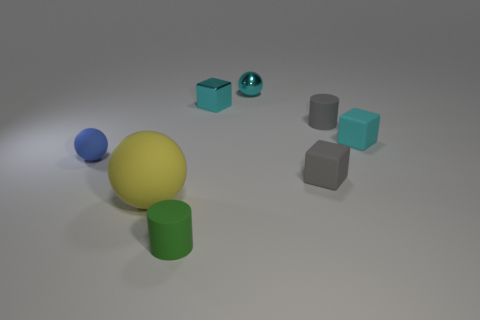Subtract all cyan blocks. How many blocks are left? 1 Subtract all gray balls. How many cyan cubes are left? 2 Add 2 cyan spheres. How many objects exist? 10 Subtract all cubes. How many objects are left? 5 Subtract all tiny green cylinders. Subtract all green matte objects. How many objects are left? 6 Add 7 balls. How many balls are left? 10 Add 6 shiny objects. How many shiny objects exist? 8 Subtract 1 cyan spheres. How many objects are left? 7 